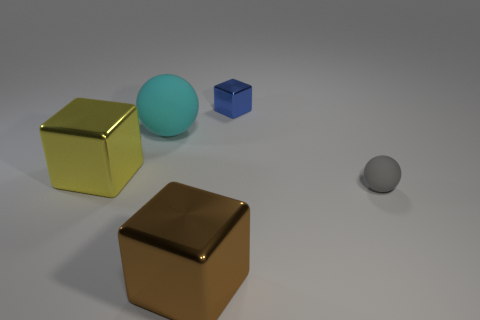There is a tiny metal block; does it have the same color as the big metallic object that is right of the big yellow block?
Give a very brief answer. No. How many other things are there of the same material as the small gray object?
Offer a terse response. 1. Is the number of purple metal blocks greater than the number of tiny metal blocks?
Your answer should be compact. No. Do the large cube behind the small gray sphere and the big ball have the same color?
Provide a succinct answer. No. The small metallic object is what color?
Give a very brief answer. Blue. There is a large metal object on the left side of the big matte thing; are there any yellow objects on the left side of it?
Your answer should be very brief. No. The rubber thing on the left side of the block that is in front of the yellow metal cube is what shape?
Offer a very short reply. Sphere. Are there fewer big yellow metal blocks than large yellow rubber spheres?
Give a very brief answer. No. Do the yellow block and the big cyan thing have the same material?
Provide a succinct answer. No. What is the color of the thing that is in front of the yellow metallic thing and to the left of the tiny gray object?
Offer a very short reply. Brown. 